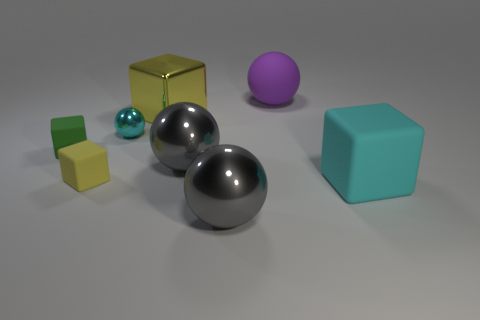How many other things are there of the same size as the matte sphere?
Provide a short and direct response. 4. Does the small metal sphere have the same color as the large matte block?
Offer a terse response. Yes. Do the big matte thing in front of the small shiny object and the tiny metallic ball have the same color?
Your response must be concise. Yes. What is the size of the rubber thing that is behind the big shiny cube?
Make the answer very short. Large. There is a block that is made of the same material as the small cyan thing; what is its color?
Your answer should be compact. Yellow. Is the number of big yellow metal cubes less than the number of big brown matte cylinders?
Ensure brevity in your answer.  No. The gray object right of the gray shiny thing that is behind the tiny matte object that is on the right side of the green rubber object is made of what material?
Your response must be concise. Metal. What material is the tiny cyan thing?
Offer a very short reply. Metal. There is a metallic object that is behind the tiny sphere; does it have the same color as the tiny rubber object on the right side of the tiny green block?
Give a very brief answer. Yes. Are there more big brown balls than cyan rubber objects?
Provide a succinct answer. No. 